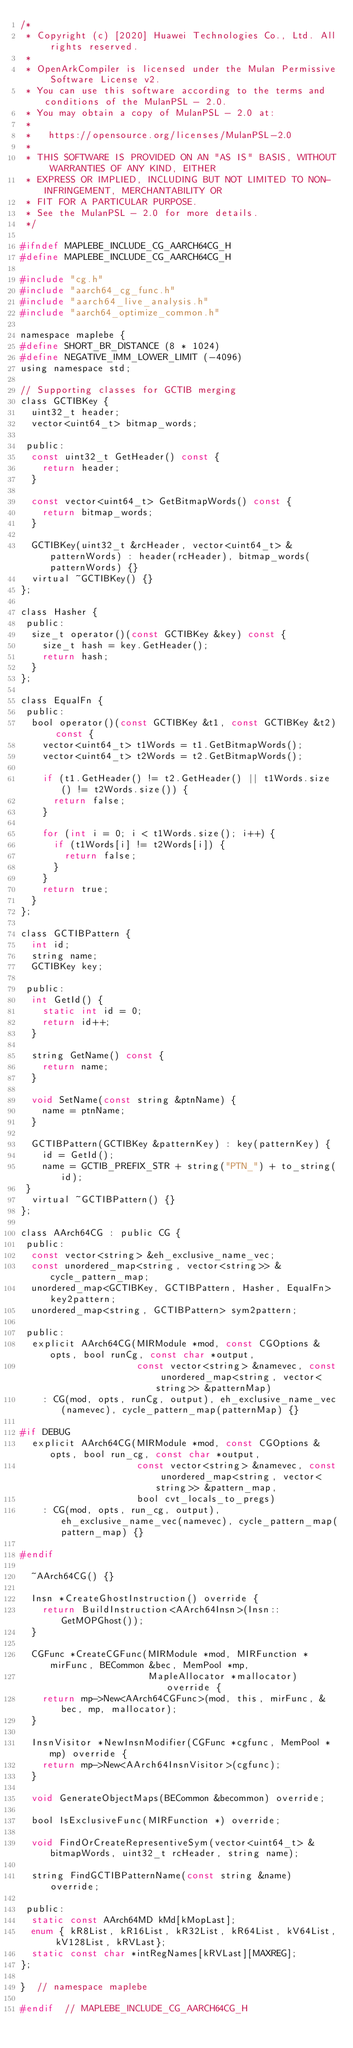Convert code to text. <code><loc_0><loc_0><loc_500><loc_500><_C_>/*
 * Copyright (c) [2020] Huawei Technologies Co., Ltd. All rights reserved.
 *
 * OpenArkCompiler is licensed under the Mulan Permissive Software License v2.
 * You can use this software according to the terms and conditions of the MulanPSL - 2.0.
 * You may obtain a copy of MulanPSL - 2.0 at:
 *
 *   https://opensource.org/licenses/MulanPSL-2.0
 *
 * THIS SOFTWARE IS PROVIDED ON AN "AS IS" BASIS, WITHOUT WARRANTIES OF ANY KIND, EITHER
 * EXPRESS OR IMPLIED, INCLUDING BUT NOT LIMITED TO NON-INFRINGEMENT, MERCHANTABILITY OR
 * FIT FOR A PARTICULAR PURPOSE.
 * See the MulanPSL - 2.0 for more details.
 */

#ifndef MAPLEBE_INCLUDE_CG_AARCH64CG_H
#define MAPLEBE_INCLUDE_CG_AARCH64CG_H

#include "cg.h"
#include "aarch64_cg_func.h"
#include "aarch64_live_analysis.h"
#include "aarch64_optimize_common.h"

namespace maplebe {
#define SHORT_BR_DISTANCE (8 * 1024)
#define NEGATIVE_IMM_LOWER_LIMIT (-4096)
using namespace std;

// Supporting classes for GCTIB merging
class GCTIBKey {
  uint32_t header;
  vector<uint64_t> bitmap_words;

 public:
  const uint32_t GetHeader() const {
    return header;
  }

  const vector<uint64_t> GetBitmapWords() const {
    return bitmap_words;
  }

  GCTIBKey(uint32_t &rcHeader, vector<uint64_t> &patternWords) : header(rcHeader), bitmap_words(patternWords) {}
  virtual ~GCTIBKey() {}
};

class Hasher {
 public:
  size_t operator()(const GCTIBKey &key) const {
    size_t hash = key.GetHeader();
    return hash;
  }
};

class EqualFn {
 public:
  bool operator()(const GCTIBKey &t1, const GCTIBKey &t2) const {
    vector<uint64_t> t1Words = t1.GetBitmapWords();
    vector<uint64_t> t2Words = t2.GetBitmapWords();

    if (t1.GetHeader() != t2.GetHeader() || t1Words.size() != t2Words.size()) {
      return false;
    }

    for (int i = 0; i < t1Words.size(); i++) {
      if (t1Words[i] != t2Words[i]) {
        return false;
      }
    }
    return true;
  }
};

class GCTIBPattern {
  int id;
  string name;
  GCTIBKey key;

 public:
  int GetId() {
    static int id = 0;
    return id++;
  }

  string GetName() const {
    return name;
  }

  void SetName(const string &ptnName) {
    name = ptnName;
  }

  GCTIBPattern(GCTIBKey &patternKey) : key(patternKey) {
    id = GetId();
    name = GCTIB_PREFIX_STR + string("PTN_") + to_string(id);
 }
  virtual ~GCTIBPattern() {}
};

class AArch64CG : public CG {
 public:
  const vector<string> &eh_exclusive_name_vec;
  const unordered_map<string, vector<string>> &cycle_pattern_map;
  unordered_map<GCTIBKey, GCTIBPattern, Hasher, EqualFn> key2pattern;
  unordered_map<string, GCTIBPattern> sym2pattern;

 public:
  explicit AArch64CG(MIRModule *mod, const CGOptions &opts, bool runCg, const char *output,
                     const vector<string> &namevec, const unordered_map<string, vector<string>> &patternMap)
    : CG(mod, opts, runCg, output), eh_exclusive_name_vec(namevec), cycle_pattern_map(patternMap) {}

#if DEBUG
  explicit AArch64CG(MIRModule *mod, const CGOptions &opts, bool run_cg, const char *output,
                     const vector<string> &namevec, const unordered_map<string, vector<string>> &pattern_map,
                     bool cvt_locals_to_pregs)
    : CG(mod, opts, run_cg, output), eh_exclusive_name_vec(namevec), cycle_pattern_map(pattern_map) {}

#endif

  ~AArch64CG() {}

  Insn *CreateGhostInstruction() override {
    return BuildInstruction<AArch64Insn>(Insn::GetMOPGhost());
  }

  CGFunc *CreateCGFunc(MIRModule *mod, MIRFunction *mirFunc, BECommon &bec, MemPool *mp,
                       MapleAllocator *mallocator) override {
    return mp->New<AArch64CGFunc>(mod, this, mirFunc, &bec, mp, mallocator);
  }

  InsnVisitor *NewInsnModifier(CGFunc *cgfunc, MemPool *mp) override {
    return mp->New<AArch64InsnVisitor>(cgfunc);
  }

  void GenerateObjectMaps(BECommon &becommon) override;

  bool IsExclusiveFunc(MIRFunction *) override;

  void FindOrCreateRepresentiveSym(vector<uint64_t> &bitmapWords, uint32_t rcHeader, string name);

  string FindGCTIBPatternName(const string &name) override;

 public:
  static const AArch64MD kMd[kMopLast];
  enum { kR8List, kR16List, kR32List, kR64List, kV64List, kV128List, kRVLast};
  static const char *intRegNames[kRVLast][MAXREG];
};

}  // namespace maplebe

#endif  // MAPLEBE_INCLUDE_CG_AARCH64CG_H
</code> 